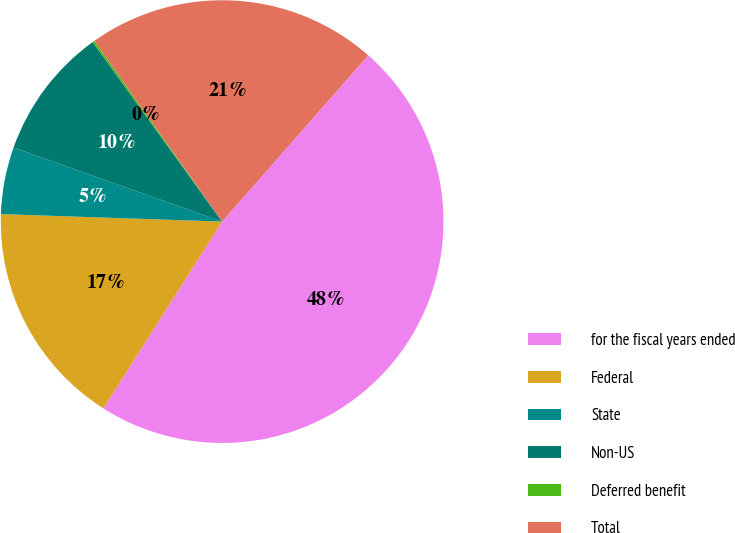Convert chart. <chart><loc_0><loc_0><loc_500><loc_500><pie_chart><fcel>for the fiscal years ended<fcel>Federal<fcel>State<fcel>Non-US<fcel>Deferred benefit<fcel>Total<nl><fcel>47.55%<fcel>16.53%<fcel>4.89%<fcel>9.63%<fcel>0.15%<fcel>21.27%<nl></chart> 